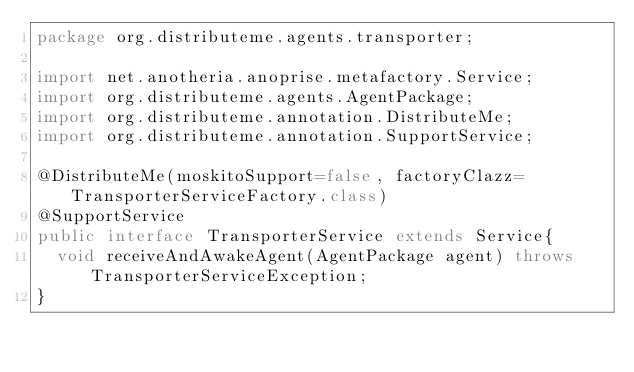Convert code to text. <code><loc_0><loc_0><loc_500><loc_500><_Java_>package org.distributeme.agents.transporter;

import net.anotheria.anoprise.metafactory.Service;
import org.distributeme.agents.AgentPackage;
import org.distributeme.annotation.DistributeMe;
import org.distributeme.annotation.SupportService;

@DistributeMe(moskitoSupport=false, factoryClazz=TransporterServiceFactory.class)
@SupportService
public interface TransporterService extends Service{
	void receiveAndAwakeAgent(AgentPackage agent) throws TransporterServiceException;
}
</code> 